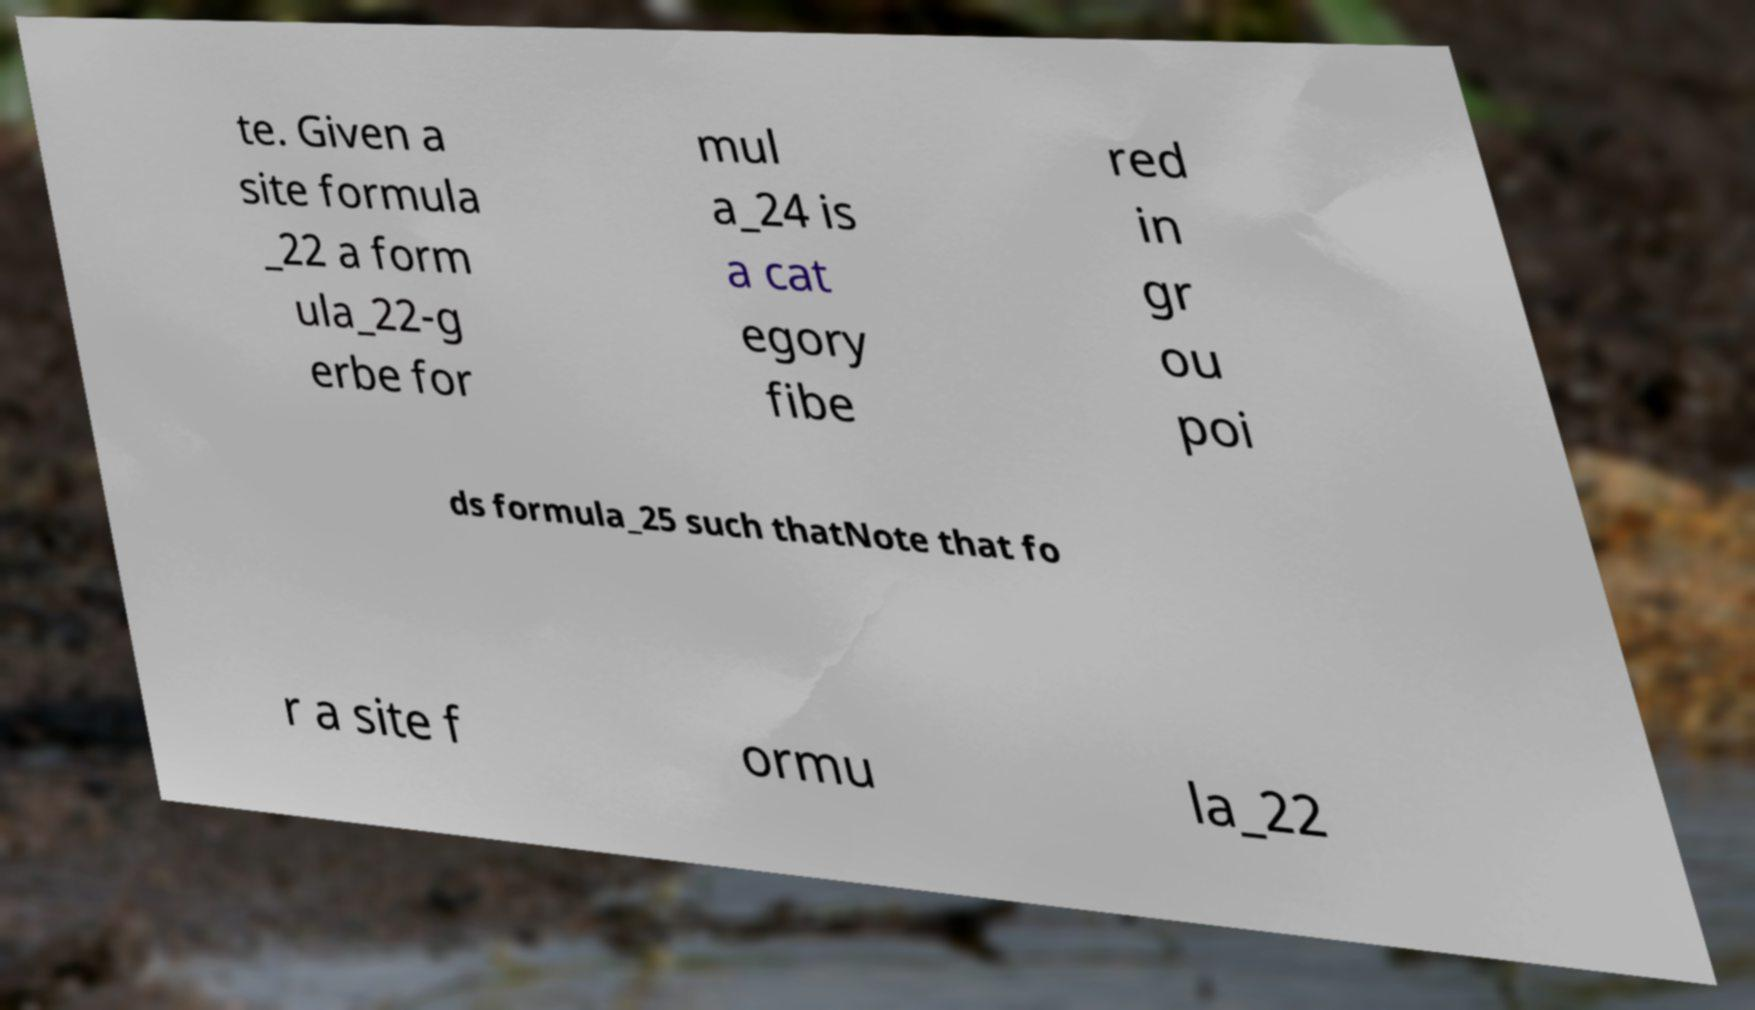For documentation purposes, I need the text within this image transcribed. Could you provide that? te. Given a site formula _22 a form ula_22-g erbe for mul a_24 is a cat egory fibe red in gr ou poi ds formula_25 such thatNote that fo r a site f ormu la_22 